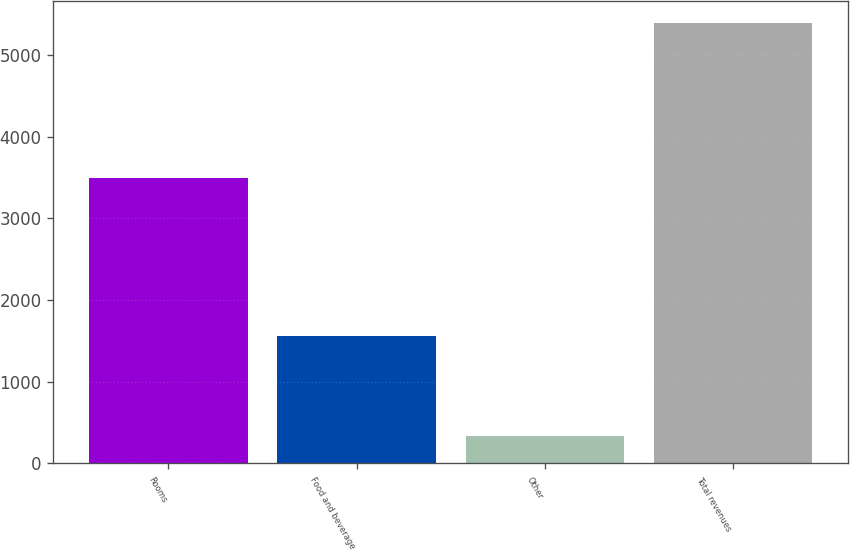<chart> <loc_0><loc_0><loc_500><loc_500><bar_chart><fcel>Rooms<fcel>Food and beverage<fcel>Other<fcel>Total revenues<nl><fcel>3490<fcel>1561<fcel>336<fcel>5387<nl></chart> 